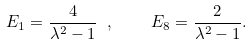<formula> <loc_0><loc_0><loc_500><loc_500>E _ { 1 } = \frac { 4 } { \lambda ^ { 2 } - 1 } \ , \quad E _ { 8 } = \frac { 2 } { \lambda ^ { 2 } - 1 } .</formula> 